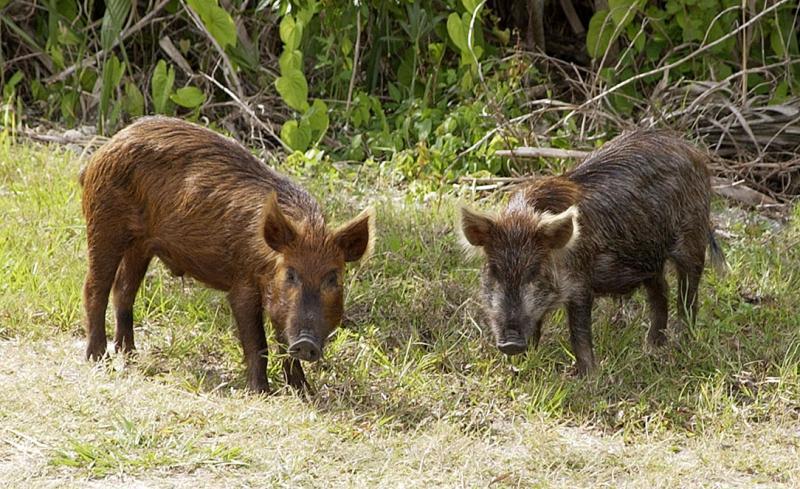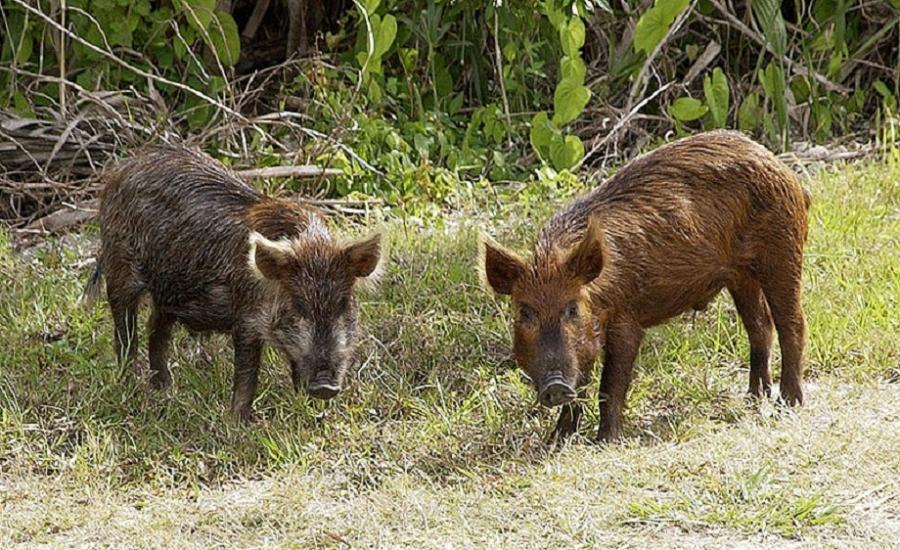The first image is the image on the left, the second image is the image on the right. Examine the images to the left and right. Is the description "There are two animals in the picture on the left." accurate? Answer yes or no. Yes. 